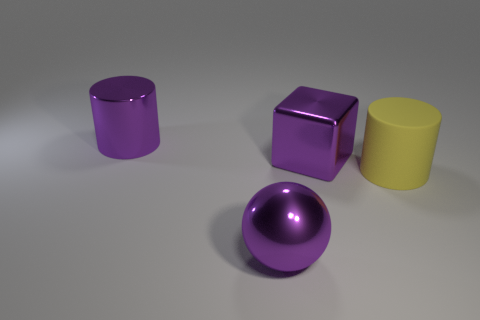Add 1 tiny red metal cubes. How many objects exist? 5 Subtract all balls. How many objects are left? 3 Add 4 purple things. How many purple things exist? 7 Subtract 0 green cylinders. How many objects are left? 4 Subtract all purple spheres. Subtract all yellow things. How many objects are left? 2 Add 3 big yellow rubber cylinders. How many big yellow rubber cylinders are left? 4 